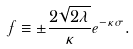Convert formula to latex. <formula><loc_0><loc_0><loc_500><loc_500>f \equiv \pm \frac { 2 \sqrt { 2 \lambda } } { \kappa } e ^ { - \kappa \sigma } .</formula> 